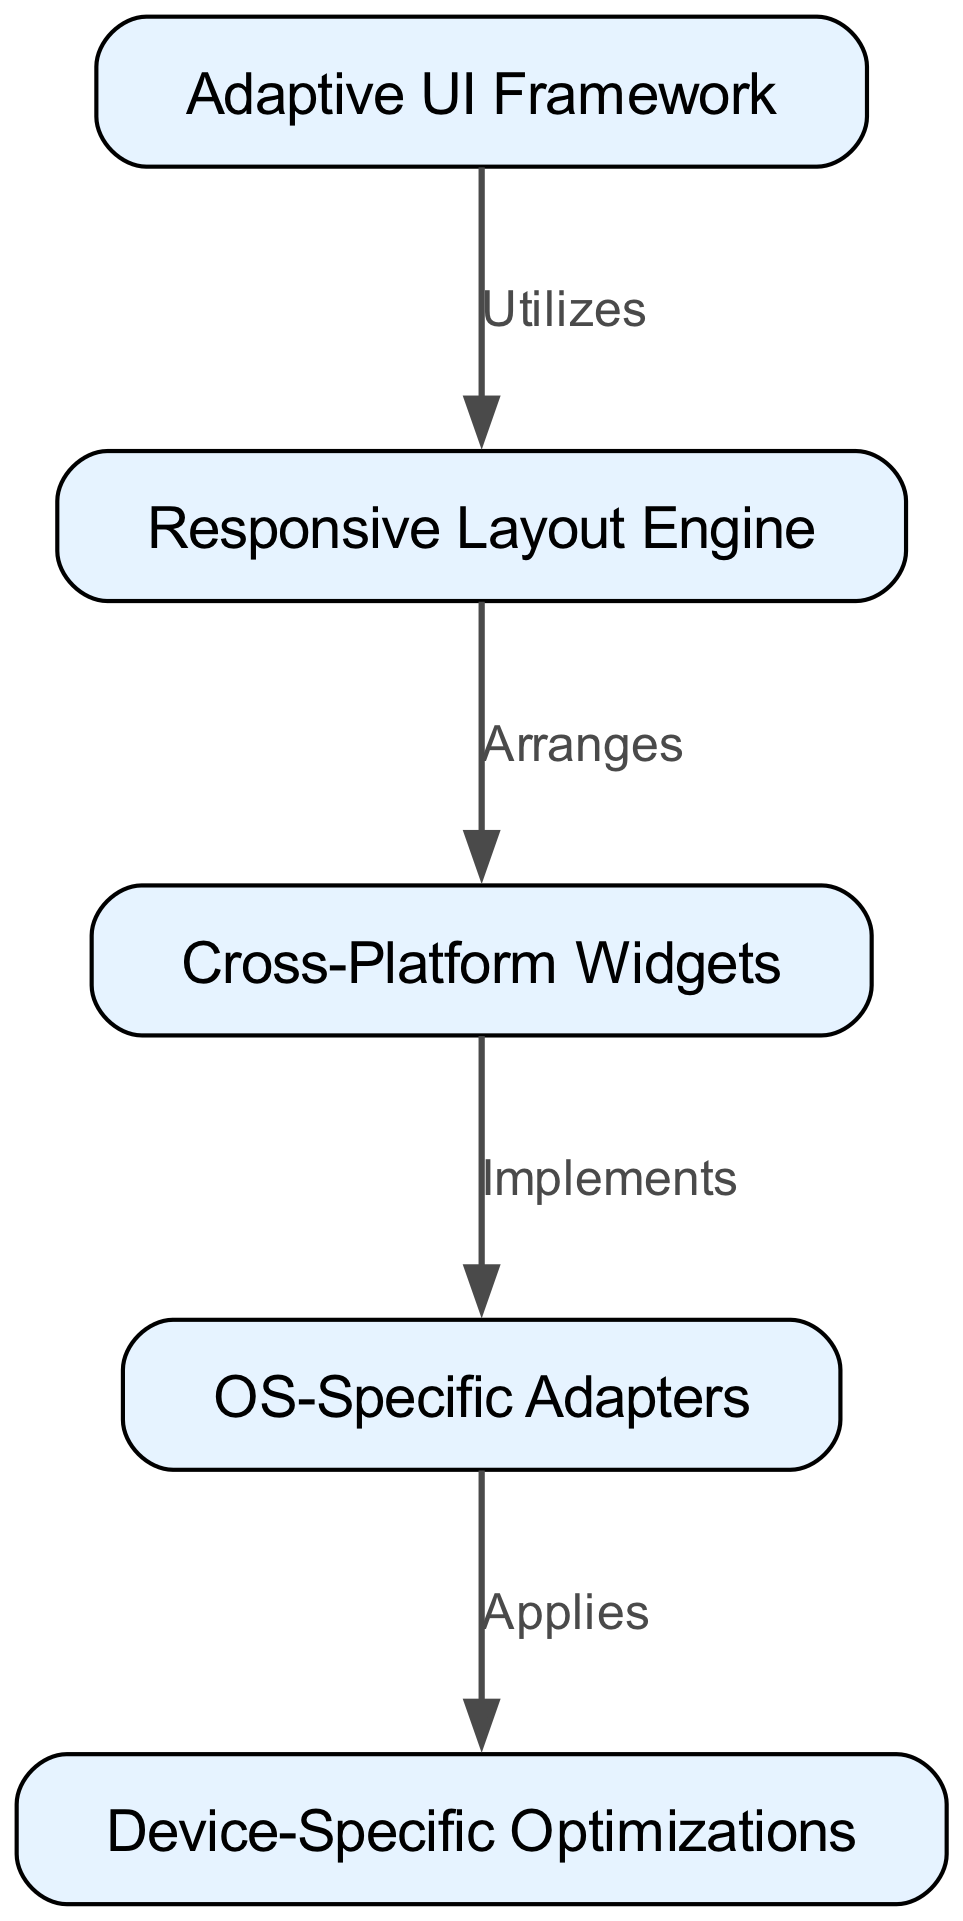What is the title of the diagram? The title is indicated in the comment at the top of the graph, which states "Adaptive UI Components Hierarchy." This represents the main topic that the diagram addresses.
Answer: Adaptive UI Components Hierarchy How many nodes are there in the diagram? The nodes are listed in the "nodes" section of the data provided. There are five entries: Adaptive UI Framework, Responsive Layout Engine, Cross-Platform Widgets, OS-Specific Adapters, and Device-Specific Optimizations, leading to a total of five nodes.
Answer: 5 Which node is the starting point of the hierarchy? The hierarchy starts with the node labeled "Adaptive UI Framework," as it is the first node in the list and acts as the root in the flow of the diagram.
Answer: Adaptive UI Framework What label connects the "Responsive Layout Engine" and "Cross-Platform Widgets"? The connecting label is "Arranges," which specifies the relationship between these two components in the hierarchy, detailing how the layout engine organizes the widgets.
Answer: Arranges What relationship does the "OS-Specific Adapters" have with "Device-Specific Optimizations"? The relationship is labeled "Applies," which indicates that the OS-Specific Adapters make use of the Device-Specific Optimizations to tailor performance for specific devices.
Answer: Applies Which node directly implements the "Cross-Platform Widgets"? The "Cross-Platform Widgets" node is directly implemented by the "OS-Specific Adapters," as shown by the edge that forms a connection between these two nodes in the diagram.
Answer: OS-Specific Adapters What is the significance of the edge labeled "Utilizes" in the diagram? This edge indicates a functional relationship where the "Adaptive UI Framework" makes use of the "Responsive Layout Engine" to enable adaptable user interfaces across different screen sizes and operating systems.
Answer: Utilizes How does "Responsive Layout Engine" relate to "Device-Specific Optimizations"? The "Responsive Layout Engine" indirectly connects to "Device-Specific Optimizations" through "Cross-Platform Widgets" and "OS-Specific Adapters," forming a chain of influence rather than direct connection.
Answer: Indirectly related Which node depends on the output of "Cross-Platform Widgets"? The node that directly depends on the output of "Cross-Platform Widgets" is the "OS-Specific Adapters," as it implements and works with the widgets to optimize for various operating systems.
Answer: OS-Specific Adapters 